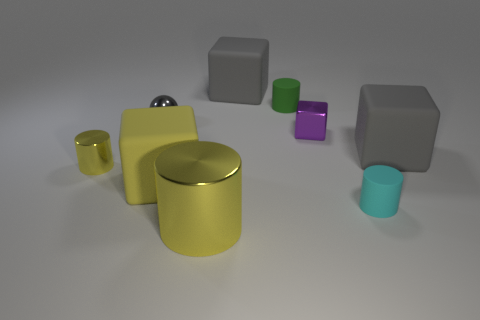Subtract all tiny yellow cylinders. How many cylinders are left? 3 Subtract all yellow cubes. How many cubes are left? 3 Subtract all cyan blocks. Subtract all brown cylinders. How many blocks are left? 4 Add 1 large brown metallic spheres. How many objects exist? 10 Subtract all balls. How many objects are left? 8 Add 4 cyan cylinders. How many cyan cylinders are left? 5 Add 1 gray shiny objects. How many gray shiny objects exist? 2 Subtract 0 blue spheres. How many objects are left? 9 Subtract all small cylinders. Subtract all tiny rubber objects. How many objects are left? 4 